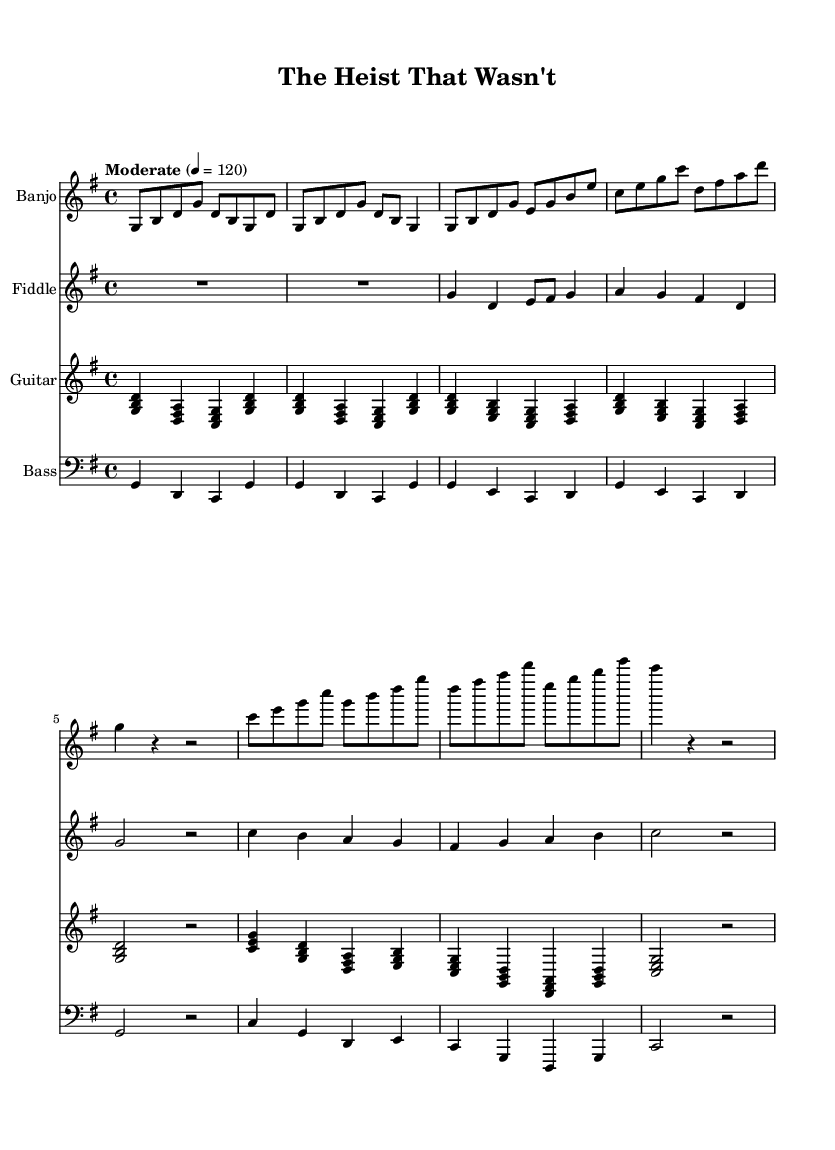What is the key signature of this music? The key signature is G major, which contains one sharp (F#). It is identified by the presence of the sharp symbol on the F line in the staff at the beginning of the piece.
Answer: G major What is the time signature of this music? The time signature is 4/4, which indicates there are four beats per measure. It's recognized by the notation that appears at the beginning of the music and dictates the rhythm structure throughout the piece.
Answer: 4/4 What is the tempo marking for this piece? The tempo marking is “Moderate” set at 4 = 120, meaning the quarter note gets a beat of 120 beats per minute. This information gives the performer guidance on how fast to play the piece.
Answer: Moderate 4 = 120 How many measures are in the chorus section? The chorus consists of four distinct measures based on the counting of the bars in the written music for the chorus, which is simplified and presented clearly.
Answer: 4 What musical instruments are featured in this piece? The featured instruments include the banjo, fiddle, guitar, and bass as indicated at the beginning of each staff in the score layout.
Answer: Banjo, fiddle, guitar, bass Which instrument plays the highest pitch in the intro section? The fiddle plays the highest pitch during the intro as it maintains a more elevated range compared to the notes played by the other instruments. It can be deduced by analyzing the range of each instrument's notation.
Answer: Fiddle What genre does this music style represent? The genre represented in this piece is Country Rock, characterized by its blending of traditional country instrumentation with rock music elements, as suggested by the arrangement and thematic content of the piece.
Answer: Country Rock 